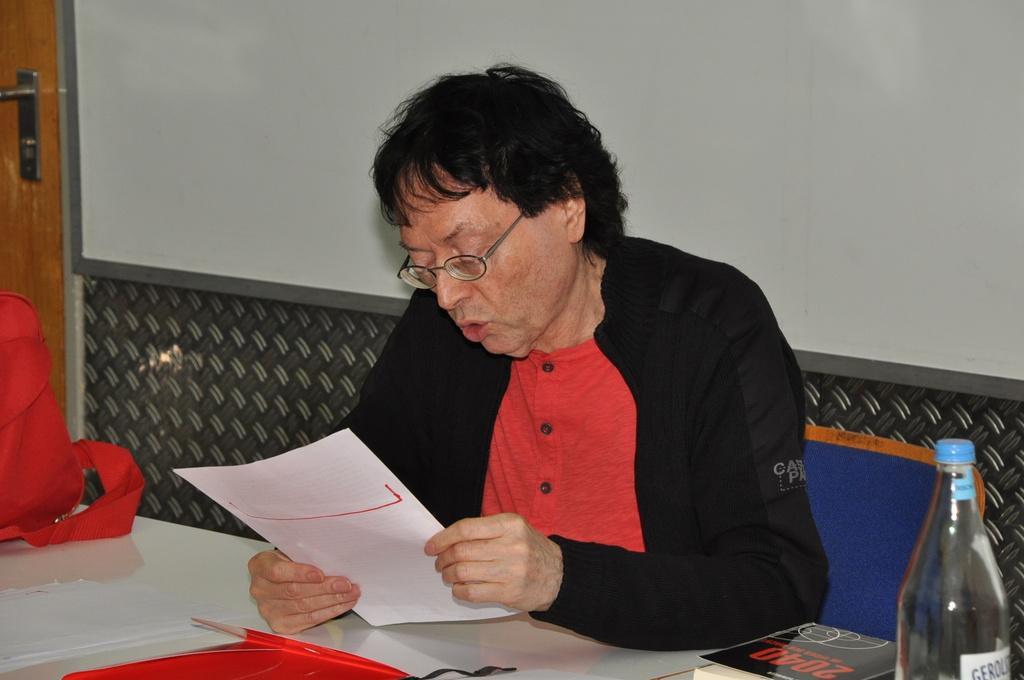Can you describe this image briefly? In this image i can see a person sitting on a chair, is wearing a black jacket and a red shirt holding a paper, there are few papers, bottle, book, a red bag on a table at the back ground i can see w whiteboard and a door. 